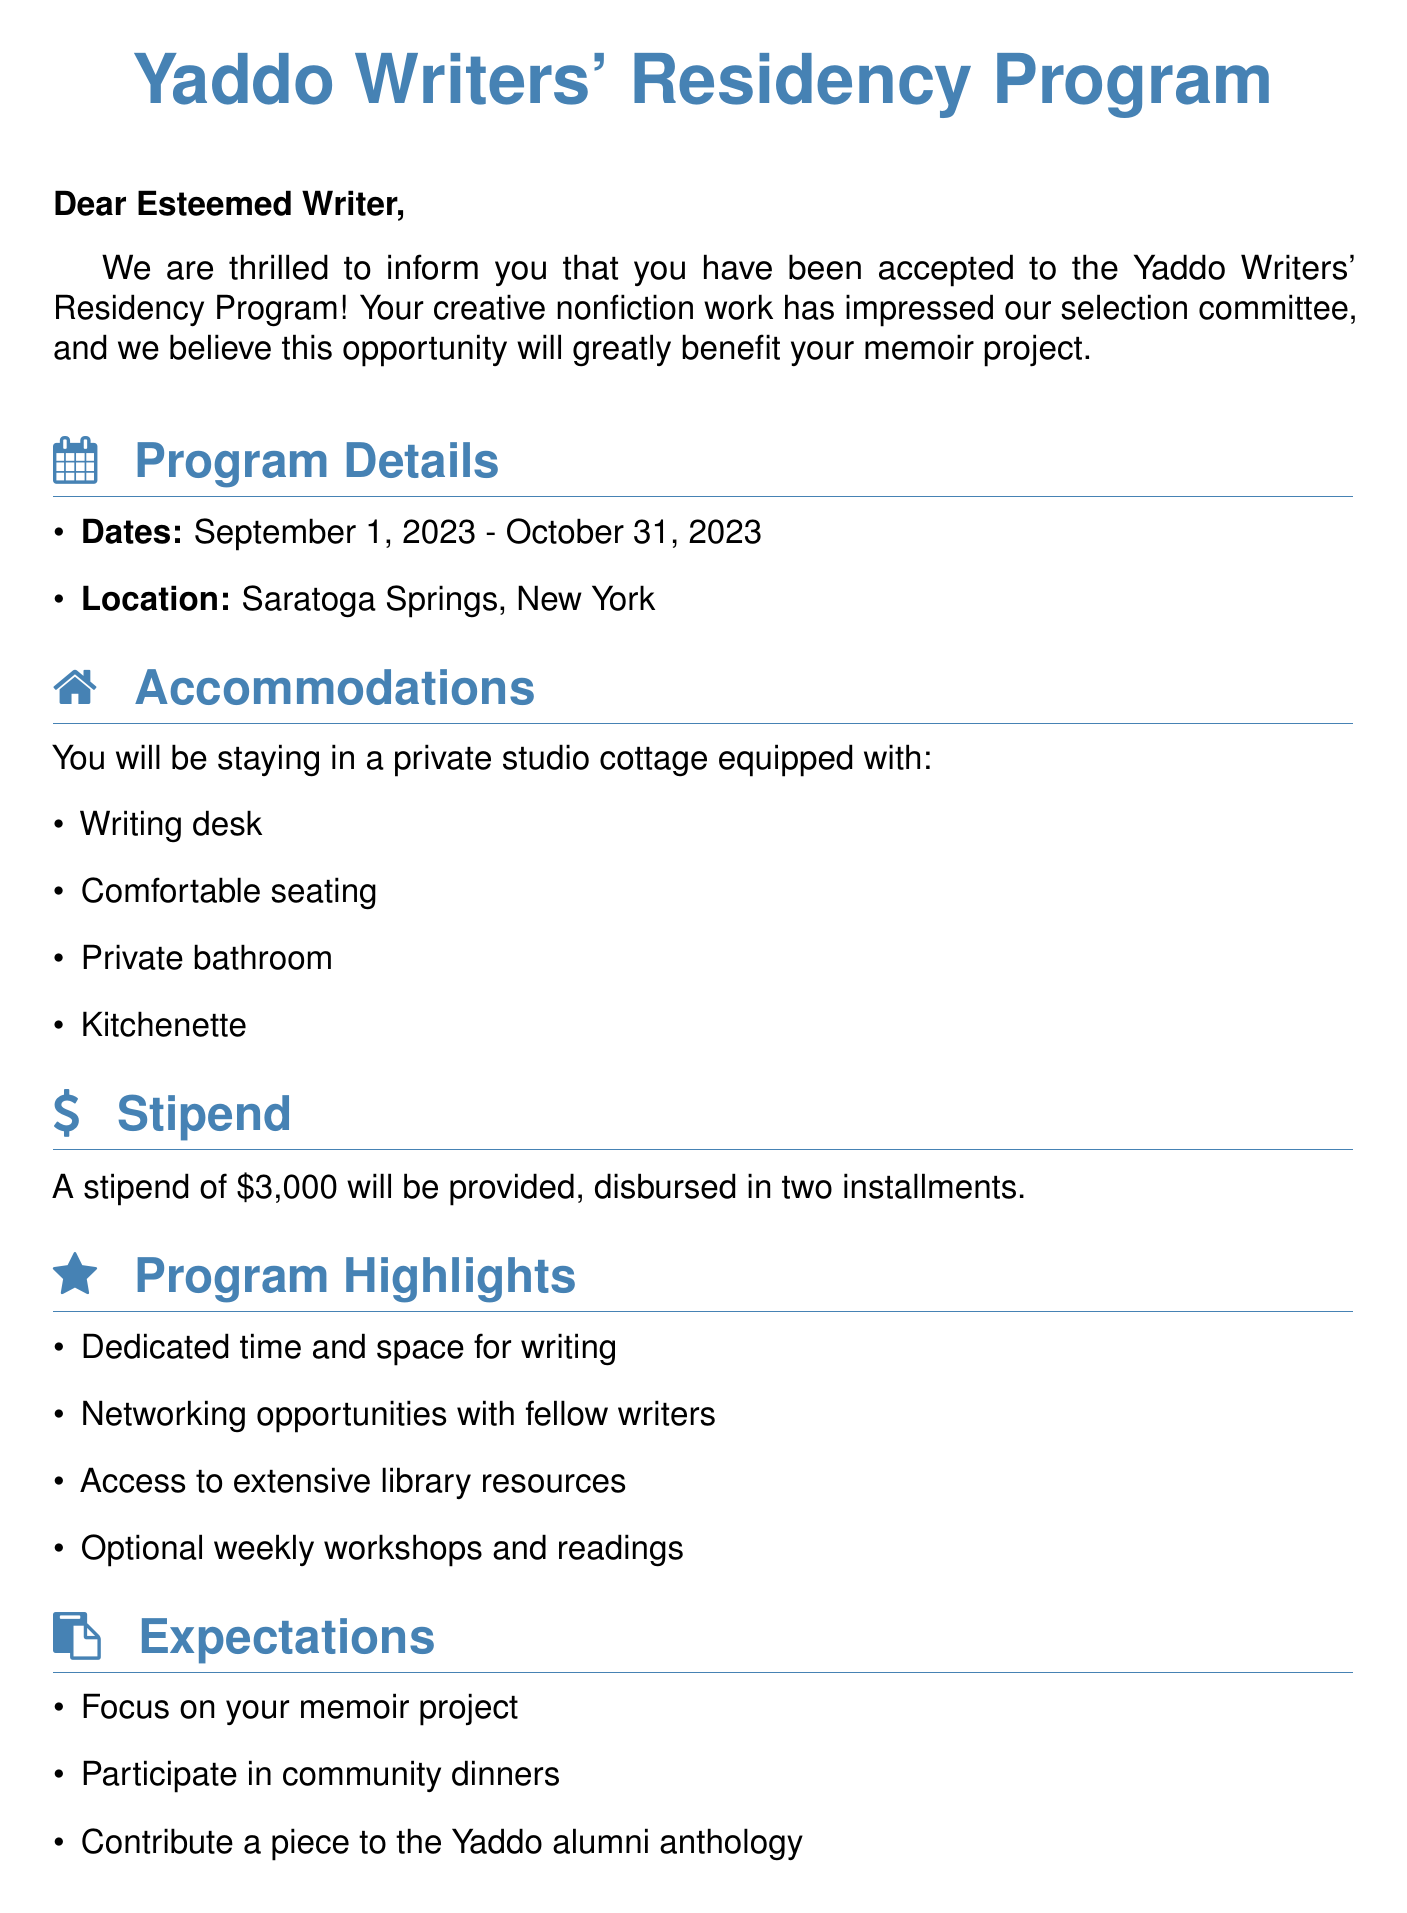What is the name of the residency program? The name of the residency program is mentioned in the title of the document.
Answer: Yaddo Writers' Residency Program What are the residency start and end dates? The start and end dates are listed in the program details section.
Answer: September 1, 2023 - October 31, 2023 What is the stipend amount provided? The stipend amount is specified in the stipend section of the document.
Answer: $3,000 What type of accommodations will be provided? The accommodations type is described in the accommodations section.
Answer: Private studio cottage Who should I contact for questions? The contact person is identified at the end of the document for any queries.
Answer: Emily Whitman What must participants contribute to the Yaddo alumni anthology? This expectation is mentioned in the expectations section of the document.
Answer: A piece What networking opportunities are available? The program highlights include various networking opportunities.
Answer: Networking opportunities with fellow writers How is the stipend payment scheduled? The payment schedule is outlined in the stipend details section of the document.
Answer: Disbursed in two installments 